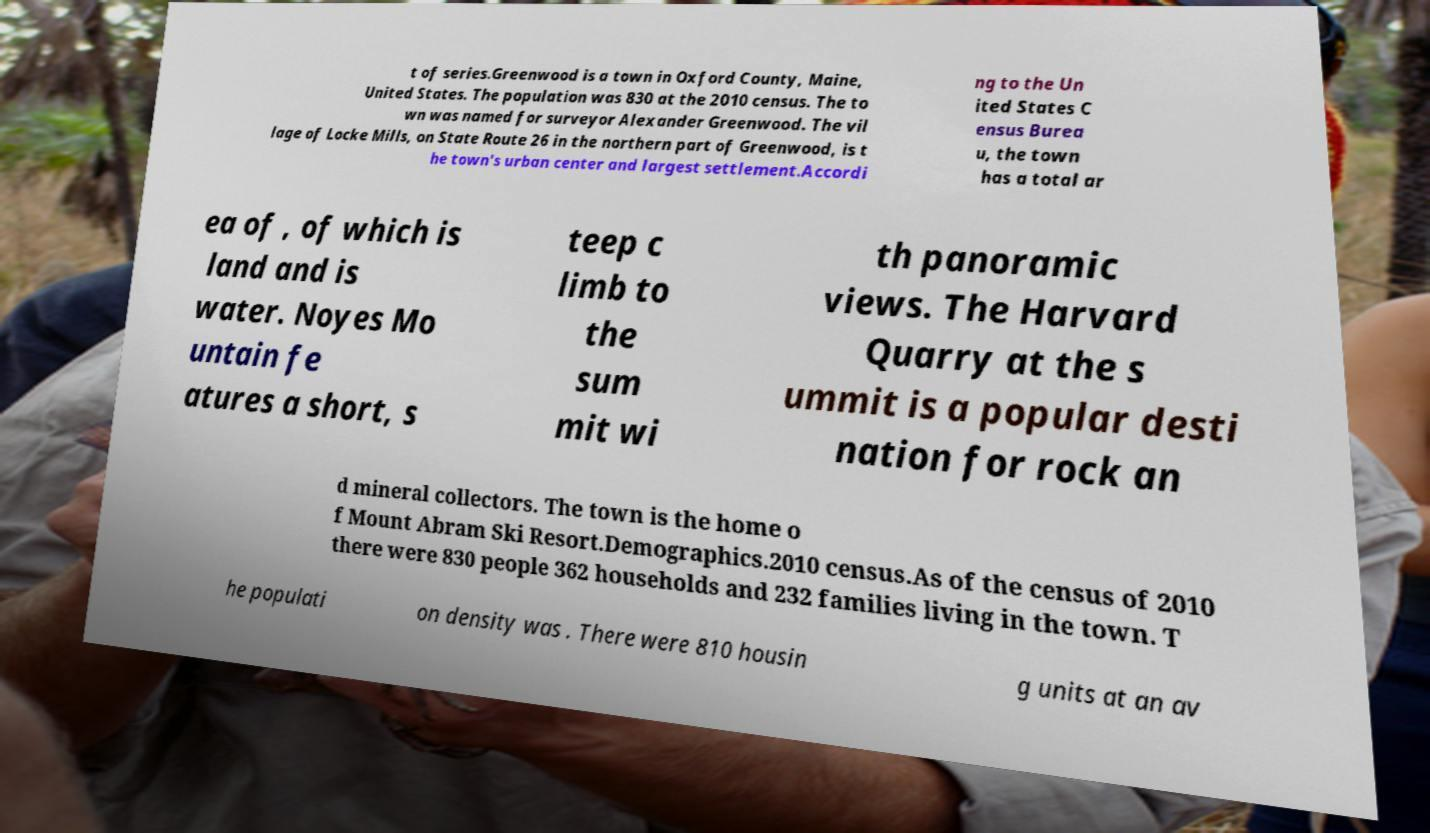Can you read and provide the text displayed in the image?This photo seems to have some interesting text. Can you extract and type it out for me? t of series.Greenwood is a town in Oxford County, Maine, United States. The population was 830 at the 2010 census. The to wn was named for surveyor Alexander Greenwood. The vil lage of Locke Mills, on State Route 26 in the northern part of Greenwood, is t he town's urban center and largest settlement.Accordi ng to the Un ited States C ensus Burea u, the town has a total ar ea of , of which is land and is water. Noyes Mo untain fe atures a short, s teep c limb to the sum mit wi th panoramic views. The Harvard Quarry at the s ummit is a popular desti nation for rock an d mineral collectors. The town is the home o f Mount Abram Ski Resort.Demographics.2010 census.As of the census of 2010 there were 830 people 362 households and 232 families living in the town. T he populati on density was . There were 810 housin g units at an av 